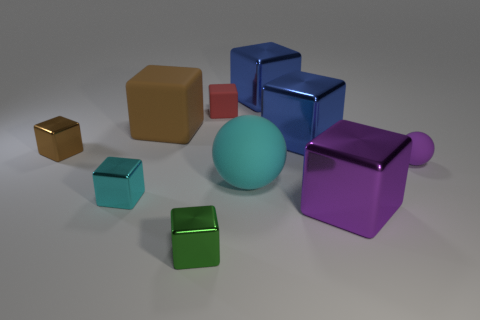Subtract 1 blocks. How many blocks are left? 7 Subtract all red cubes. How many cubes are left? 7 Subtract all cyan metal blocks. How many blocks are left? 7 Subtract all green blocks. Subtract all green spheres. How many blocks are left? 7 Subtract all balls. How many objects are left? 8 Add 2 big cyan matte objects. How many big cyan matte objects exist? 3 Subtract 0 gray balls. How many objects are left? 10 Subtract all yellow shiny blocks. Subtract all matte blocks. How many objects are left? 8 Add 2 small red objects. How many small red objects are left? 3 